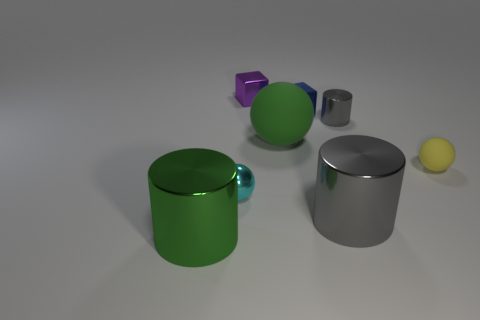Are there more blue shiny objects in front of the big gray cylinder than tiny cyan objects behind the small purple block?
Offer a terse response. No. What material is the object that is the same color as the big ball?
Provide a succinct answer. Metal. Are there any other things that have the same shape as the tiny blue thing?
Make the answer very short. Yes. What is the thing that is both on the left side of the big sphere and behind the green matte thing made of?
Offer a very short reply. Metal. Is the small purple object made of the same material as the small block that is right of the large sphere?
Offer a terse response. Yes. Are there any other things that have the same size as the green metal cylinder?
Your answer should be very brief. Yes. What number of objects are small matte objects or metallic cylinders in front of the yellow matte sphere?
Give a very brief answer. 3. Do the green object that is in front of the small yellow thing and the gray shiny cylinder in front of the yellow matte ball have the same size?
Offer a terse response. Yes. What number of other objects are there of the same color as the metallic sphere?
Make the answer very short. 0. Is the size of the green metallic cylinder the same as the metallic sphere that is left of the big gray object?
Your response must be concise. No. 